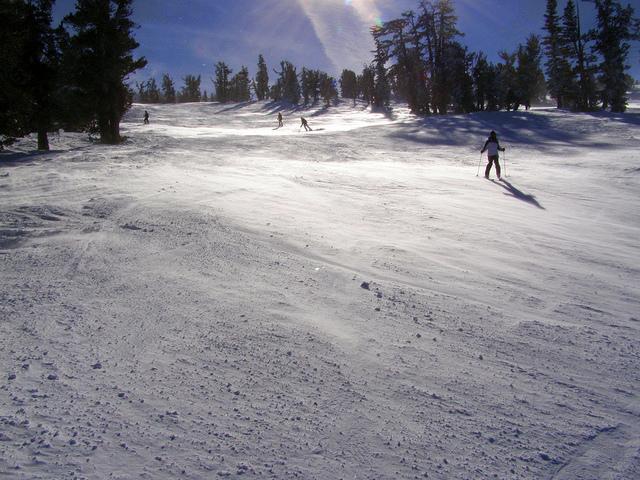Is it a clear day or overcast?
Quick response, please. Clear. What caused the green dot on the photo?
Be succinct. Sunlight. Are the tree covered with snow?
Keep it brief. No. Are the clouds in the sky?
Write a very short answer. Yes. Is this fresh, newly fallen snow?
Keep it brief. No. What is covering the trees?
Give a very brief answer. Snow. What season is this?
Write a very short answer. Winter. Are the trees covered in snow?
Write a very short answer. No. What are the trees covered with?
Write a very short answer. Snow. How many skiers are in the photo?
Answer briefly. 4. 